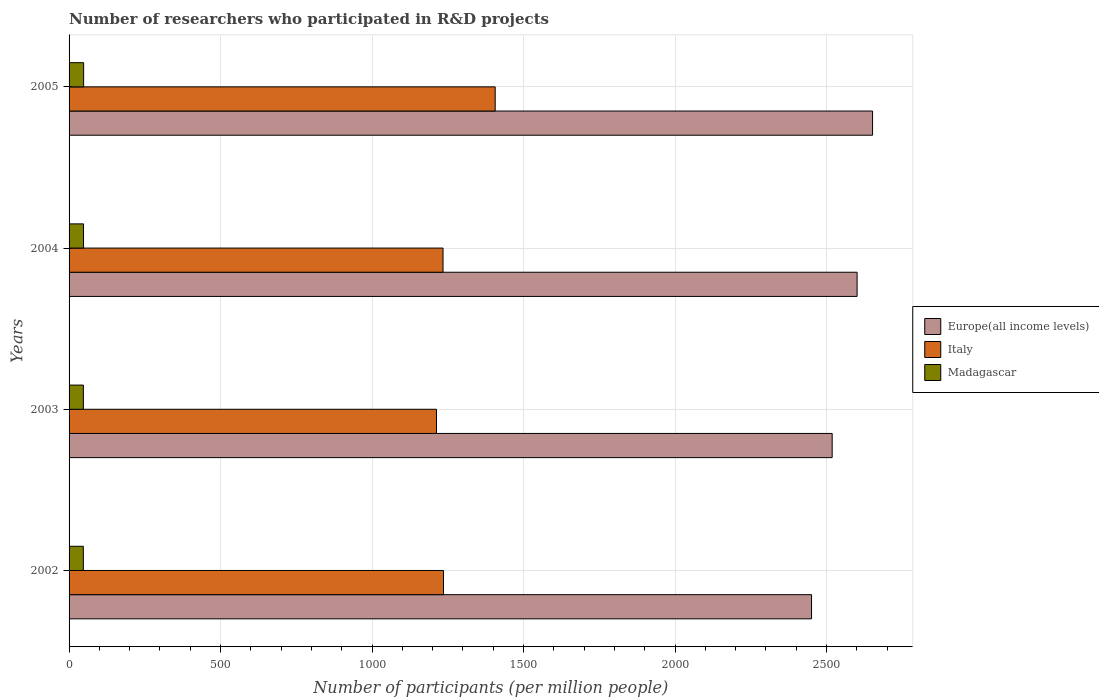How many different coloured bars are there?
Give a very brief answer. 3. How many groups of bars are there?
Your answer should be very brief. 4. Are the number of bars per tick equal to the number of legend labels?
Keep it short and to the point. Yes. Are the number of bars on each tick of the Y-axis equal?
Ensure brevity in your answer.  Yes. How many bars are there on the 4th tick from the bottom?
Offer a very short reply. 3. What is the number of researchers who participated in R&D projects in Europe(all income levels) in 2004?
Your answer should be very brief. 2600.71. Across all years, what is the maximum number of researchers who participated in R&D projects in Europe(all income levels)?
Your response must be concise. 2651.73. Across all years, what is the minimum number of researchers who participated in R&D projects in Italy?
Offer a very short reply. 1212.58. In which year was the number of researchers who participated in R&D projects in Italy minimum?
Provide a succinct answer. 2003. What is the total number of researchers who participated in R&D projects in Madagascar in the graph?
Offer a terse response. 190.08. What is the difference between the number of researchers who participated in R&D projects in Madagascar in 2003 and that in 2005?
Your response must be concise. -0.86. What is the difference between the number of researchers who participated in R&D projects in Europe(all income levels) in 2005 and the number of researchers who participated in R&D projects in Madagascar in 2003?
Your response must be concise. 2604.53. What is the average number of researchers who participated in R&D projects in Italy per year?
Offer a very short reply. 1272.17. In the year 2005, what is the difference between the number of researchers who participated in R&D projects in Europe(all income levels) and number of researchers who participated in R&D projects in Italy?
Make the answer very short. 1245.44. What is the ratio of the number of researchers who participated in R&D projects in Italy in 2002 to that in 2004?
Offer a terse response. 1. Is the number of researchers who participated in R&D projects in Madagascar in 2002 less than that in 2003?
Your answer should be compact. Yes. Is the difference between the number of researchers who participated in R&D projects in Europe(all income levels) in 2002 and 2004 greater than the difference between the number of researchers who participated in R&D projects in Italy in 2002 and 2004?
Your answer should be compact. No. What is the difference between the highest and the second highest number of researchers who participated in R&D projects in Europe(all income levels)?
Your answer should be compact. 51.02. What is the difference between the highest and the lowest number of researchers who participated in R&D projects in Italy?
Provide a succinct answer. 193.7. Is the sum of the number of researchers who participated in R&D projects in Italy in 2002 and 2003 greater than the maximum number of researchers who participated in R&D projects in Europe(all income levels) across all years?
Ensure brevity in your answer.  No. What does the 1st bar from the top in 2002 represents?
Your response must be concise. Madagascar. What does the 1st bar from the bottom in 2004 represents?
Make the answer very short. Europe(all income levels). How many years are there in the graph?
Your answer should be very brief. 4. What is the difference between two consecutive major ticks on the X-axis?
Ensure brevity in your answer.  500. Does the graph contain any zero values?
Keep it short and to the point. No. Does the graph contain grids?
Your answer should be compact. Yes. How are the legend labels stacked?
Provide a succinct answer. Vertical. What is the title of the graph?
Make the answer very short. Number of researchers who participated in R&D projects. Does "South Sudan" appear as one of the legend labels in the graph?
Give a very brief answer. No. What is the label or title of the X-axis?
Your answer should be compact. Number of participants (per million people). What is the label or title of the Y-axis?
Provide a short and direct response. Years. What is the Number of participants (per million people) of Europe(all income levels) in 2002?
Your response must be concise. 2450.36. What is the Number of participants (per million people) in Italy in 2002?
Your response must be concise. 1235.65. What is the Number of participants (per million people) in Madagascar in 2002?
Ensure brevity in your answer.  47.08. What is the Number of participants (per million people) in Europe(all income levels) in 2003?
Your answer should be compact. 2518.44. What is the Number of participants (per million people) in Italy in 2003?
Make the answer very short. 1212.58. What is the Number of participants (per million people) in Madagascar in 2003?
Your answer should be very brief. 47.2. What is the Number of participants (per million people) in Europe(all income levels) in 2004?
Your response must be concise. 2600.71. What is the Number of participants (per million people) of Italy in 2004?
Offer a very short reply. 1234.18. What is the Number of participants (per million people) in Madagascar in 2004?
Ensure brevity in your answer.  47.74. What is the Number of participants (per million people) of Europe(all income levels) in 2005?
Ensure brevity in your answer.  2651.73. What is the Number of participants (per million people) of Italy in 2005?
Offer a terse response. 1406.28. What is the Number of participants (per million people) in Madagascar in 2005?
Keep it short and to the point. 48.06. Across all years, what is the maximum Number of participants (per million people) in Europe(all income levels)?
Your answer should be very brief. 2651.73. Across all years, what is the maximum Number of participants (per million people) in Italy?
Keep it short and to the point. 1406.28. Across all years, what is the maximum Number of participants (per million people) in Madagascar?
Ensure brevity in your answer.  48.06. Across all years, what is the minimum Number of participants (per million people) in Europe(all income levels)?
Make the answer very short. 2450.36. Across all years, what is the minimum Number of participants (per million people) of Italy?
Offer a terse response. 1212.58. Across all years, what is the minimum Number of participants (per million people) of Madagascar?
Offer a very short reply. 47.08. What is the total Number of participants (per million people) in Europe(all income levels) in the graph?
Give a very brief answer. 1.02e+04. What is the total Number of participants (per million people) in Italy in the graph?
Offer a terse response. 5088.69. What is the total Number of participants (per million people) of Madagascar in the graph?
Provide a succinct answer. 190.08. What is the difference between the Number of participants (per million people) of Europe(all income levels) in 2002 and that in 2003?
Give a very brief answer. -68.08. What is the difference between the Number of participants (per million people) of Italy in 2002 and that in 2003?
Your response must be concise. 23.06. What is the difference between the Number of participants (per million people) in Madagascar in 2002 and that in 2003?
Offer a terse response. -0.12. What is the difference between the Number of participants (per million people) in Europe(all income levels) in 2002 and that in 2004?
Your response must be concise. -150.35. What is the difference between the Number of participants (per million people) in Italy in 2002 and that in 2004?
Your answer should be very brief. 1.47. What is the difference between the Number of participants (per million people) of Madagascar in 2002 and that in 2004?
Give a very brief answer. -0.65. What is the difference between the Number of participants (per million people) in Europe(all income levels) in 2002 and that in 2005?
Your answer should be compact. -201.37. What is the difference between the Number of participants (per million people) in Italy in 2002 and that in 2005?
Offer a terse response. -170.64. What is the difference between the Number of participants (per million people) of Madagascar in 2002 and that in 2005?
Give a very brief answer. -0.97. What is the difference between the Number of participants (per million people) in Europe(all income levels) in 2003 and that in 2004?
Provide a succinct answer. -82.28. What is the difference between the Number of participants (per million people) of Italy in 2003 and that in 2004?
Provide a short and direct response. -21.59. What is the difference between the Number of participants (per million people) of Madagascar in 2003 and that in 2004?
Give a very brief answer. -0.54. What is the difference between the Number of participants (per million people) in Europe(all income levels) in 2003 and that in 2005?
Offer a very short reply. -133.29. What is the difference between the Number of participants (per million people) of Italy in 2003 and that in 2005?
Make the answer very short. -193.7. What is the difference between the Number of participants (per million people) of Madagascar in 2003 and that in 2005?
Give a very brief answer. -0.86. What is the difference between the Number of participants (per million people) in Europe(all income levels) in 2004 and that in 2005?
Your answer should be compact. -51.02. What is the difference between the Number of participants (per million people) in Italy in 2004 and that in 2005?
Provide a short and direct response. -172.11. What is the difference between the Number of participants (per million people) of Madagascar in 2004 and that in 2005?
Your answer should be very brief. -0.32. What is the difference between the Number of participants (per million people) in Europe(all income levels) in 2002 and the Number of participants (per million people) in Italy in 2003?
Ensure brevity in your answer.  1237.78. What is the difference between the Number of participants (per million people) in Europe(all income levels) in 2002 and the Number of participants (per million people) in Madagascar in 2003?
Offer a very short reply. 2403.16. What is the difference between the Number of participants (per million people) in Italy in 2002 and the Number of participants (per million people) in Madagascar in 2003?
Keep it short and to the point. 1188.44. What is the difference between the Number of participants (per million people) of Europe(all income levels) in 2002 and the Number of participants (per million people) of Italy in 2004?
Your answer should be compact. 1216.18. What is the difference between the Number of participants (per million people) in Europe(all income levels) in 2002 and the Number of participants (per million people) in Madagascar in 2004?
Ensure brevity in your answer.  2402.62. What is the difference between the Number of participants (per million people) of Italy in 2002 and the Number of participants (per million people) of Madagascar in 2004?
Give a very brief answer. 1187.91. What is the difference between the Number of participants (per million people) in Europe(all income levels) in 2002 and the Number of participants (per million people) in Italy in 2005?
Ensure brevity in your answer.  1044.08. What is the difference between the Number of participants (per million people) of Europe(all income levels) in 2002 and the Number of participants (per million people) of Madagascar in 2005?
Make the answer very short. 2402.3. What is the difference between the Number of participants (per million people) of Italy in 2002 and the Number of participants (per million people) of Madagascar in 2005?
Provide a succinct answer. 1187.59. What is the difference between the Number of participants (per million people) in Europe(all income levels) in 2003 and the Number of participants (per million people) in Italy in 2004?
Ensure brevity in your answer.  1284.26. What is the difference between the Number of participants (per million people) in Europe(all income levels) in 2003 and the Number of participants (per million people) in Madagascar in 2004?
Provide a succinct answer. 2470.7. What is the difference between the Number of participants (per million people) in Italy in 2003 and the Number of participants (per million people) in Madagascar in 2004?
Give a very brief answer. 1164.85. What is the difference between the Number of participants (per million people) in Europe(all income levels) in 2003 and the Number of participants (per million people) in Italy in 2005?
Make the answer very short. 1112.15. What is the difference between the Number of participants (per million people) of Europe(all income levels) in 2003 and the Number of participants (per million people) of Madagascar in 2005?
Provide a short and direct response. 2470.38. What is the difference between the Number of participants (per million people) of Italy in 2003 and the Number of participants (per million people) of Madagascar in 2005?
Give a very brief answer. 1164.53. What is the difference between the Number of participants (per million people) of Europe(all income levels) in 2004 and the Number of participants (per million people) of Italy in 2005?
Make the answer very short. 1194.43. What is the difference between the Number of participants (per million people) in Europe(all income levels) in 2004 and the Number of participants (per million people) in Madagascar in 2005?
Give a very brief answer. 2552.65. What is the difference between the Number of participants (per million people) in Italy in 2004 and the Number of participants (per million people) in Madagascar in 2005?
Provide a short and direct response. 1186.12. What is the average Number of participants (per million people) in Europe(all income levels) per year?
Keep it short and to the point. 2555.31. What is the average Number of participants (per million people) of Italy per year?
Make the answer very short. 1272.17. What is the average Number of participants (per million people) of Madagascar per year?
Give a very brief answer. 47.52. In the year 2002, what is the difference between the Number of participants (per million people) of Europe(all income levels) and Number of participants (per million people) of Italy?
Provide a short and direct response. 1214.71. In the year 2002, what is the difference between the Number of participants (per million people) in Europe(all income levels) and Number of participants (per million people) in Madagascar?
Give a very brief answer. 2403.28. In the year 2002, what is the difference between the Number of participants (per million people) of Italy and Number of participants (per million people) of Madagascar?
Your answer should be very brief. 1188.56. In the year 2003, what is the difference between the Number of participants (per million people) of Europe(all income levels) and Number of participants (per million people) of Italy?
Make the answer very short. 1305.85. In the year 2003, what is the difference between the Number of participants (per million people) of Europe(all income levels) and Number of participants (per million people) of Madagascar?
Your response must be concise. 2471.23. In the year 2003, what is the difference between the Number of participants (per million people) of Italy and Number of participants (per million people) of Madagascar?
Keep it short and to the point. 1165.38. In the year 2004, what is the difference between the Number of participants (per million people) in Europe(all income levels) and Number of participants (per million people) in Italy?
Ensure brevity in your answer.  1366.54. In the year 2004, what is the difference between the Number of participants (per million people) in Europe(all income levels) and Number of participants (per million people) in Madagascar?
Offer a very short reply. 2552.97. In the year 2004, what is the difference between the Number of participants (per million people) in Italy and Number of participants (per million people) in Madagascar?
Your answer should be very brief. 1186.44. In the year 2005, what is the difference between the Number of participants (per million people) in Europe(all income levels) and Number of participants (per million people) in Italy?
Make the answer very short. 1245.44. In the year 2005, what is the difference between the Number of participants (per million people) of Europe(all income levels) and Number of participants (per million people) of Madagascar?
Offer a very short reply. 2603.67. In the year 2005, what is the difference between the Number of participants (per million people) of Italy and Number of participants (per million people) of Madagascar?
Give a very brief answer. 1358.23. What is the ratio of the Number of participants (per million people) of Italy in 2002 to that in 2003?
Your response must be concise. 1.02. What is the ratio of the Number of participants (per million people) in Europe(all income levels) in 2002 to that in 2004?
Keep it short and to the point. 0.94. What is the ratio of the Number of participants (per million people) of Madagascar in 2002 to that in 2004?
Provide a succinct answer. 0.99. What is the ratio of the Number of participants (per million people) of Europe(all income levels) in 2002 to that in 2005?
Ensure brevity in your answer.  0.92. What is the ratio of the Number of participants (per million people) in Italy in 2002 to that in 2005?
Provide a short and direct response. 0.88. What is the ratio of the Number of participants (per million people) in Madagascar in 2002 to that in 2005?
Offer a very short reply. 0.98. What is the ratio of the Number of participants (per million people) in Europe(all income levels) in 2003 to that in 2004?
Your answer should be compact. 0.97. What is the ratio of the Number of participants (per million people) of Italy in 2003 to that in 2004?
Ensure brevity in your answer.  0.98. What is the ratio of the Number of participants (per million people) in Madagascar in 2003 to that in 2004?
Make the answer very short. 0.99. What is the ratio of the Number of participants (per million people) of Europe(all income levels) in 2003 to that in 2005?
Your answer should be compact. 0.95. What is the ratio of the Number of participants (per million people) in Italy in 2003 to that in 2005?
Offer a terse response. 0.86. What is the ratio of the Number of participants (per million people) of Madagascar in 2003 to that in 2005?
Your answer should be very brief. 0.98. What is the ratio of the Number of participants (per million people) of Europe(all income levels) in 2004 to that in 2005?
Your answer should be compact. 0.98. What is the ratio of the Number of participants (per million people) in Italy in 2004 to that in 2005?
Your answer should be very brief. 0.88. What is the difference between the highest and the second highest Number of participants (per million people) in Europe(all income levels)?
Give a very brief answer. 51.02. What is the difference between the highest and the second highest Number of participants (per million people) of Italy?
Give a very brief answer. 170.64. What is the difference between the highest and the second highest Number of participants (per million people) of Madagascar?
Provide a succinct answer. 0.32. What is the difference between the highest and the lowest Number of participants (per million people) in Europe(all income levels)?
Your answer should be compact. 201.37. What is the difference between the highest and the lowest Number of participants (per million people) of Italy?
Offer a terse response. 193.7. What is the difference between the highest and the lowest Number of participants (per million people) of Madagascar?
Ensure brevity in your answer.  0.97. 